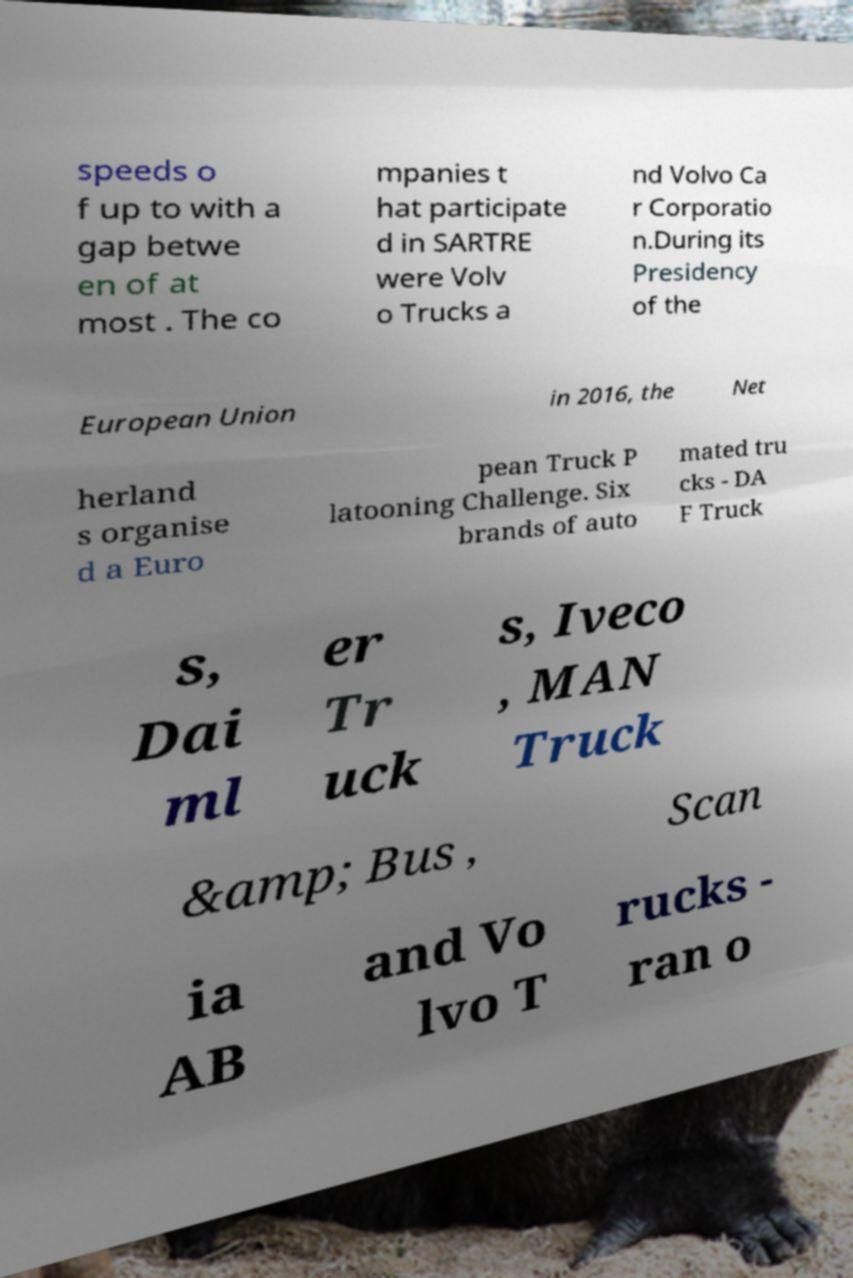What messages or text are displayed in this image? I need them in a readable, typed format. speeds o f up to with a gap betwe en of at most . The co mpanies t hat participate d in SARTRE were Volv o Trucks a nd Volvo Ca r Corporatio n.During its Presidency of the European Union in 2016, the Net herland s organise d a Euro pean Truck P latooning Challenge. Six brands of auto mated tru cks - DA F Truck s, Dai ml er Tr uck s, Iveco , MAN Truck &amp; Bus , Scan ia AB and Vo lvo T rucks - ran o 